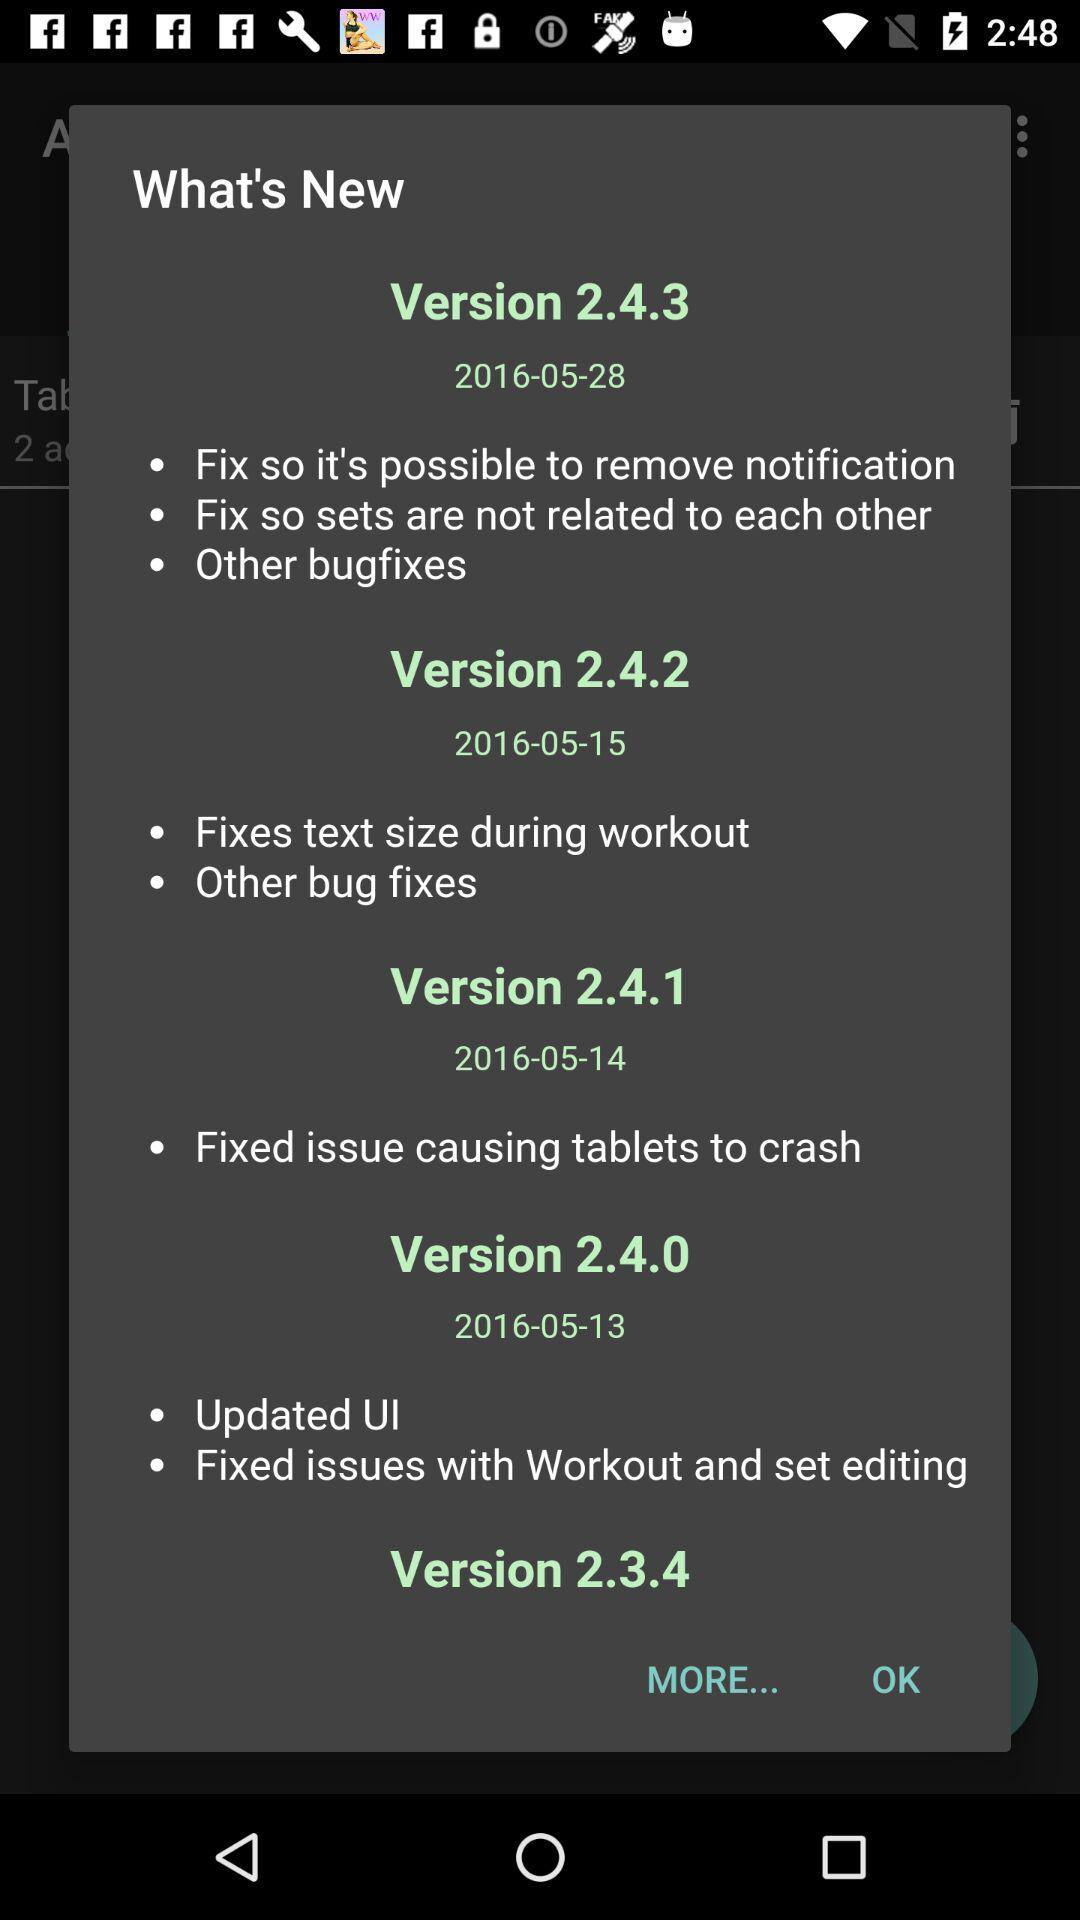What are the new features in version 2.4.3? The new features in version 2.4.3 are "Fix so it's possible to remove notification", "Fix so sets are not related to each other" and "Other bugfixes". 